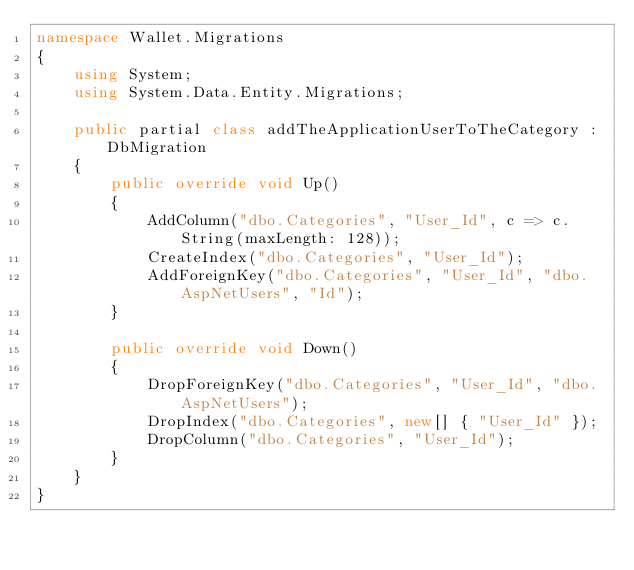<code> <loc_0><loc_0><loc_500><loc_500><_C#_>namespace Wallet.Migrations
{
    using System;
    using System.Data.Entity.Migrations;
    
    public partial class addTheApplicationUserToTheCategory : DbMigration
    {
        public override void Up()
        {
            AddColumn("dbo.Categories", "User_Id", c => c.String(maxLength: 128));
            CreateIndex("dbo.Categories", "User_Id");
            AddForeignKey("dbo.Categories", "User_Id", "dbo.AspNetUsers", "Id");
        }
        
        public override void Down()
        {
            DropForeignKey("dbo.Categories", "User_Id", "dbo.AspNetUsers");
            DropIndex("dbo.Categories", new[] { "User_Id" });
            DropColumn("dbo.Categories", "User_Id");
        }
    }
}
</code> 